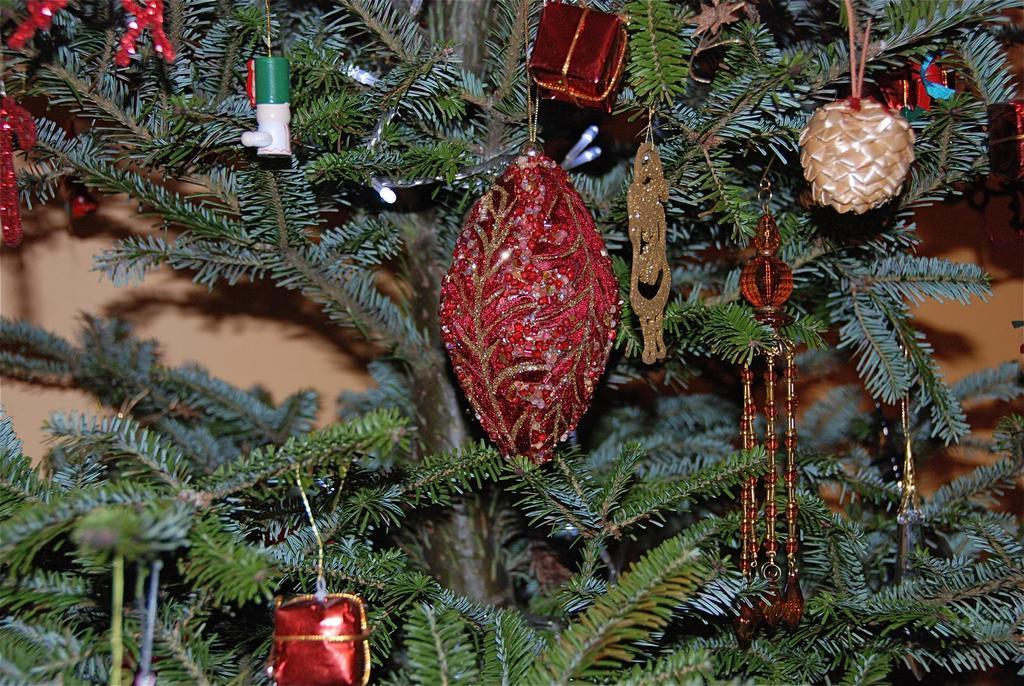Describe this image in one or two sentences. In this image I can see a tree and on it I can see decorations. 